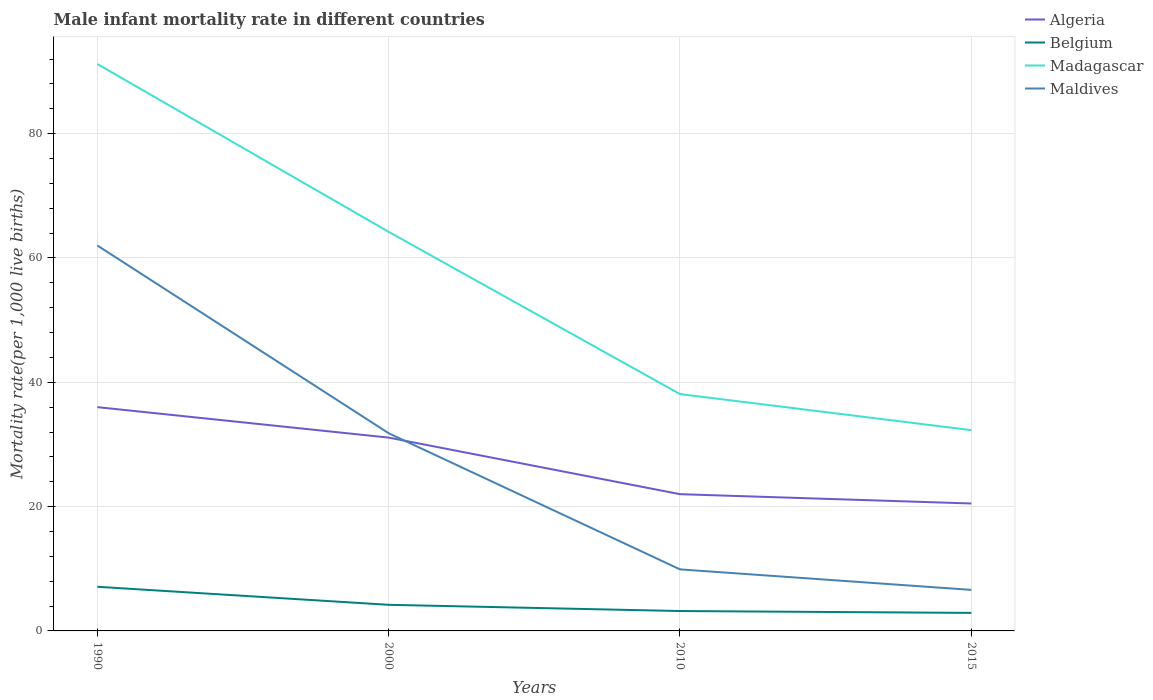How many different coloured lines are there?
Give a very brief answer. 4. Does the line corresponding to Maldives intersect with the line corresponding to Madagascar?
Your response must be concise. No. Is the number of lines equal to the number of legend labels?
Make the answer very short. Yes. In which year was the male infant mortality rate in Belgium maximum?
Your answer should be very brief. 2015. What is the total male infant mortality rate in Madagascar in the graph?
Your response must be concise. 5.8. What is the difference between the highest and the second highest male infant mortality rate in Maldives?
Keep it short and to the point. 55.4. Is the male infant mortality rate in Maldives strictly greater than the male infant mortality rate in Belgium over the years?
Your response must be concise. No. How many lines are there?
Offer a terse response. 4. How many legend labels are there?
Give a very brief answer. 4. How are the legend labels stacked?
Offer a very short reply. Vertical. What is the title of the graph?
Offer a very short reply. Male infant mortality rate in different countries. What is the label or title of the X-axis?
Provide a short and direct response. Years. What is the label or title of the Y-axis?
Provide a succinct answer. Mortality rate(per 1,0 live births). What is the Mortality rate(per 1,000 live births) in Algeria in 1990?
Provide a short and direct response. 36. What is the Mortality rate(per 1,000 live births) in Madagascar in 1990?
Offer a very short reply. 91.2. What is the Mortality rate(per 1,000 live births) in Maldives in 1990?
Offer a very short reply. 62. What is the Mortality rate(per 1,000 live births) in Algeria in 2000?
Ensure brevity in your answer.  31.1. What is the Mortality rate(per 1,000 live births) in Belgium in 2000?
Your response must be concise. 4.2. What is the Mortality rate(per 1,000 live births) in Madagascar in 2000?
Keep it short and to the point. 64.2. What is the Mortality rate(per 1,000 live births) of Maldives in 2000?
Give a very brief answer. 31.8. What is the Mortality rate(per 1,000 live births) of Madagascar in 2010?
Give a very brief answer. 38.1. What is the Mortality rate(per 1,000 live births) of Madagascar in 2015?
Provide a succinct answer. 32.3. Across all years, what is the maximum Mortality rate(per 1,000 live births) of Belgium?
Provide a succinct answer. 7.1. Across all years, what is the maximum Mortality rate(per 1,000 live births) of Madagascar?
Ensure brevity in your answer.  91.2. Across all years, what is the minimum Mortality rate(per 1,000 live births) in Algeria?
Your answer should be very brief. 20.5. Across all years, what is the minimum Mortality rate(per 1,000 live births) in Madagascar?
Give a very brief answer. 32.3. Across all years, what is the minimum Mortality rate(per 1,000 live births) of Maldives?
Provide a succinct answer. 6.6. What is the total Mortality rate(per 1,000 live births) of Algeria in the graph?
Provide a short and direct response. 109.6. What is the total Mortality rate(per 1,000 live births) of Belgium in the graph?
Provide a short and direct response. 17.4. What is the total Mortality rate(per 1,000 live births) of Madagascar in the graph?
Give a very brief answer. 225.8. What is the total Mortality rate(per 1,000 live births) in Maldives in the graph?
Provide a succinct answer. 110.3. What is the difference between the Mortality rate(per 1,000 live births) in Maldives in 1990 and that in 2000?
Give a very brief answer. 30.2. What is the difference between the Mortality rate(per 1,000 live births) in Algeria in 1990 and that in 2010?
Your answer should be very brief. 14. What is the difference between the Mortality rate(per 1,000 live births) of Madagascar in 1990 and that in 2010?
Your answer should be very brief. 53.1. What is the difference between the Mortality rate(per 1,000 live births) in Maldives in 1990 and that in 2010?
Offer a terse response. 52.1. What is the difference between the Mortality rate(per 1,000 live births) in Algeria in 1990 and that in 2015?
Keep it short and to the point. 15.5. What is the difference between the Mortality rate(per 1,000 live births) of Belgium in 1990 and that in 2015?
Your response must be concise. 4.2. What is the difference between the Mortality rate(per 1,000 live births) of Madagascar in 1990 and that in 2015?
Your answer should be very brief. 58.9. What is the difference between the Mortality rate(per 1,000 live births) of Maldives in 1990 and that in 2015?
Your answer should be very brief. 55.4. What is the difference between the Mortality rate(per 1,000 live births) of Algeria in 2000 and that in 2010?
Make the answer very short. 9.1. What is the difference between the Mortality rate(per 1,000 live births) in Madagascar in 2000 and that in 2010?
Keep it short and to the point. 26.1. What is the difference between the Mortality rate(per 1,000 live births) of Maldives in 2000 and that in 2010?
Ensure brevity in your answer.  21.9. What is the difference between the Mortality rate(per 1,000 live births) of Algeria in 2000 and that in 2015?
Offer a terse response. 10.6. What is the difference between the Mortality rate(per 1,000 live births) in Belgium in 2000 and that in 2015?
Offer a very short reply. 1.3. What is the difference between the Mortality rate(per 1,000 live births) of Madagascar in 2000 and that in 2015?
Offer a very short reply. 31.9. What is the difference between the Mortality rate(per 1,000 live births) in Maldives in 2000 and that in 2015?
Give a very brief answer. 25.2. What is the difference between the Mortality rate(per 1,000 live births) of Madagascar in 2010 and that in 2015?
Ensure brevity in your answer.  5.8. What is the difference between the Mortality rate(per 1,000 live births) in Algeria in 1990 and the Mortality rate(per 1,000 live births) in Belgium in 2000?
Your answer should be compact. 31.8. What is the difference between the Mortality rate(per 1,000 live births) of Algeria in 1990 and the Mortality rate(per 1,000 live births) of Madagascar in 2000?
Ensure brevity in your answer.  -28.2. What is the difference between the Mortality rate(per 1,000 live births) in Algeria in 1990 and the Mortality rate(per 1,000 live births) in Maldives in 2000?
Your response must be concise. 4.2. What is the difference between the Mortality rate(per 1,000 live births) in Belgium in 1990 and the Mortality rate(per 1,000 live births) in Madagascar in 2000?
Provide a succinct answer. -57.1. What is the difference between the Mortality rate(per 1,000 live births) in Belgium in 1990 and the Mortality rate(per 1,000 live births) in Maldives in 2000?
Offer a terse response. -24.7. What is the difference between the Mortality rate(per 1,000 live births) in Madagascar in 1990 and the Mortality rate(per 1,000 live births) in Maldives in 2000?
Your response must be concise. 59.4. What is the difference between the Mortality rate(per 1,000 live births) of Algeria in 1990 and the Mortality rate(per 1,000 live births) of Belgium in 2010?
Your answer should be compact. 32.8. What is the difference between the Mortality rate(per 1,000 live births) of Algeria in 1990 and the Mortality rate(per 1,000 live births) of Maldives in 2010?
Your answer should be compact. 26.1. What is the difference between the Mortality rate(per 1,000 live births) of Belgium in 1990 and the Mortality rate(per 1,000 live births) of Madagascar in 2010?
Your response must be concise. -31. What is the difference between the Mortality rate(per 1,000 live births) in Madagascar in 1990 and the Mortality rate(per 1,000 live births) in Maldives in 2010?
Offer a terse response. 81.3. What is the difference between the Mortality rate(per 1,000 live births) in Algeria in 1990 and the Mortality rate(per 1,000 live births) in Belgium in 2015?
Keep it short and to the point. 33.1. What is the difference between the Mortality rate(per 1,000 live births) in Algeria in 1990 and the Mortality rate(per 1,000 live births) in Madagascar in 2015?
Keep it short and to the point. 3.7. What is the difference between the Mortality rate(per 1,000 live births) in Algeria in 1990 and the Mortality rate(per 1,000 live births) in Maldives in 2015?
Keep it short and to the point. 29.4. What is the difference between the Mortality rate(per 1,000 live births) of Belgium in 1990 and the Mortality rate(per 1,000 live births) of Madagascar in 2015?
Give a very brief answer. -25.2. What is the difference between the Mortality rate(per 1,000 live births) of Madagascar in 1990 and the Mortality rate(per 1,000 live births) of Maldives in 2015?
Offer a terse response. 84.6. What is the difference between the Mortality rate(per 1,000 live births) of Algeria in 2000 and the Mortality rate(per 1,000 live births) of Belgium in 2010?
Your answer should be compact. 27.9. What is the difference between the Mortality rate(per 1,000 live births) in Algeria in 2000 and the Mortality rate(per 1,000 live births) in Maldives in 2010?
Your answer should be very brief. 21.2. What is the difference between the Mortality rate(per 1,000 live births) in Belgium in 2000 and the Mortality rate(per 1,000 live births) in Madagascar in 2010?
Offer a terse response. -33.9. What is the difference between the Mortality rate(per 1,000 live births) of Belgium in 2000 and the Mortality rate(per 1,000 live births) of Maldives in 2010?
Make the answer very short. -5.7. What is the difference between the Mortality rate(per 1,000 live births) in Madagascar in 2000 and the Mortality rate(per 1,000 live births) in Maldives in 2010?
Provide a succinct answer. 54.3. What is the difference between the Mortality rate(per 1,000 live births) of Algeria in 2000 and the Mortality rate(per 1,000 live births) of Belgium in 2015?
Your answer should be very brief. 28.2. What is the difference between the Mortality rate(per 1,000 live births) of Belgium in 2000 and the Mortality rate(per 1,000 live births) of Madagascar in 2015?
Offer a terse response. -28.1. What is the difference between the Mortality rate(per 1,000 live births) in Belgium in 2000 and the Mortality rate(per 1,000 live births) in Maldives in 2015?
Provide a succinct answer. -2.4. What is the difference between the Mortality rate(per 1,000 live births) of Madagascar in 2000 and the Mortality rate(per 1,000 live births) of Maldives in 2015?
Ensure brevity in your answer.  57.6. What is the difference between the Mortality rate(per 1,000 live births) of Algeria in 2010 and the Mortality rate(per 1,000 live births) of Madagascar in 2015?
Keep it short and to the point. -10.3. What is the difference between the Mortality rate(per 1,000 live births) in Algeria in 2010 and the Mortality rate(per 1,000 live births) in Maldives in 2015?
Give a very brief answer. 15.4. What is the difference between the Mortality rate(per 1,000 live births) in Belgium in 2010 and the Mortality rate(per 1,000 live births) in Madagascar in 2015?
Ensure brevity in your answer.  -29.1. What is the difference between the Mortality rate(per 1,000 live births) of Belgium in 2010 and the Mortality rate(per 1,000 live births) of Maldives in 2015?
Provide a short and direct response. -3.4. What is the difference between the Mortality rate(per 1,000 live births) in Madagascar in 2010 and the Mortality rate(per 1,000 live births) in Maldives in 2015?
Your response must be concise. 31.5. What is the average Mortality rate(per 1,000 live births) in Algeria per year?
Give a very brief answer. 27.4. What is the average Mortality rate(per 1,000 live births) in Belgium per year?
Ensure brevity in your answer.  4.35. What is the average Mortality rate(per 1,000 live births) in Madagascar per year?
Provide a succinct answer. 56.45. What is the average Mortality rate(per 1,000 live births) of Maldives per year?
Offer a very short reply. 27.57. In the year 1990, what is the difference between the Mortality rate(per 1,000 live births) in Algeria and Mortality rate(per 1,000 live births) in Belgium?
Give a very brief answer. 28.9. In the year 1990, what is the difference between the Mortality rate(per 1,000 live births) of Algeria and Mortality rate(per 1,000 live births) of Madagascar?
Keep it short and to the point. -55.2. In the year 1990, what is the difference between the Mortality rate(per 1,000 live births) of Algeria and Mortality rate(per 1,000 live births) of Maldives?
Ensure brevity in your answer.  -26. In the year 1990, what is the difference between the Mortality rate(per 1,000 live births) in Belgium and Mortality rate(per 1,000 live births) in Madagascar?
Your answer should be compact. -84.1. In the year 1990, what is the difference between the Mortality rate(per 1,000 live births) in Belgium and Mortality rate(per 1,000 live births) in Maldives?
Provide a short and direct response. -54.9. In the year 1990, what is the difference between the Mortality rate(per 1,000 live births) of Madagascar and Mortality rate(per 1,000 live births) of Maldives?
Offer a terse response. 29.2. In the year 2000, what is the difference between the Mortality rate(per 1,000 live births) in Algeria and Mortality rate(per 1,000 live births) in Belgium?
Offer a terse response. 26.9. In the year 2000, what is the difference between the Mortality rate(per 1,000 live births) of Algeria and Mortality rate(per 1,000 live births) of Madagascar?
Keep it short and to the point. -33.1. In the year 2000, what is the difference between the Mortality rate(per 1,000 live births) of Belgium and Mortality rate(per 1,000 live births) of Madagascar?
Offer a terse response. -60. In the year 2000, what is the difference between the Mortality rate(per 1,000 live births) in Belgium and Mortality rate(per 1,000 live births) in Maldives?
Keep it short and to the point. -27.6. In the year 2000, what is the difference between the Mortality rate(per 1,000 live births) in Madagascar and Mortality rate(per 1,000 live births) in Maldives?
Provide a short and direct response. 32.4. In the year 2010, what is the difference between the Mortality rate(per 1,000 live births) of Algeria and Mortality rate(per 1,000 live births) of Madagascar?
Make the answer very short. -16.1. In the year 2010, what is the difference between the Mortality rate(per 1,000 live births) of Belgium and Mortality rate(per 1,000 live births) of Madagascar?
Provide a short and direct response. -34.9. In the year 2010, what is the difference between the Mortality rate(per 1,000 live births) in Belgium and Mortality rate(per 1,000 live births) in Maldives?
Offer a terse response. -6.7. In the year 2010, what is the difference between the Mortality rate(per 1,000 live births) of Madagascar and Mortality rate(per 1,000 live births) of Maldives?
Keep it short and to the point. 28.2. In the year 2015, what is the difference between the Mortality rate(per 1,000 live births) in Algeria and Mortality rate(per 1,000 live births) in Madagascar?
Provide a short and direct response. -11.8. In the year 2015, what is the difference between the Mortality rate(per 1,000 live births) of Belgium and Mortality rate(per 1,000 live births) of Madagascar?
Your answer should be compact. -29.4. In the year 2015, what is the difference between the Mortality rate(per 1,000 live births) in Belgium and Mortality rate(per 1,000 live births) in Maldives?
Ensure brevity in your answer.  -3.7. In the year 2015, what is the difference between the Mortality rate(per 1,000 live births) in Madagascar and Mortality rate(per 1,000 live births) in Maldives?
Your answer should be very brief. 25.7. What is the ratio of the Mortality rate(per 1,000 live births) of Algeria in 1990 to that in 2000?
Provide a short and direct response. 1.16. What is the ratio of the Mortality rate(per 1,000 live births) in Belgium in 1990 to that in 2000?
Your answer should be very brief. 1.69. What is the ratio of the Mortality rate(per 1,000 live births) in Madagascar in 1990 to that in 2000?
Provide a succinct answer. 1.42. What is the ratio of the Mortality rate(per 1,000 live births) in Maldives in 1990 to that in 2000?
Keep it short and to the point. 1.95. What is the ratio of the Mortality rate(per 1,000 live births) of Algeria in 1990 to that in 2010?
Your response must be concise. 1.64. What is the ratio of the Mortality rate(per 1,000 live births) in Belgium in 1990 to that in 2010?
Provide a short and direct response. 2.22. What is the ratio of the Mortality rate(per 1,000 live births) of Madagascar in 1990 to that in 2010?
Make the answer very short. 2.39. What is the ratio of the Mortality rate(per 1,000 live births) of Maldives in 1990 to that in 2010?
Offer a terse response. 6.26. What is the ratio of the Mortality rate(per 1,000 live births) in Algeria in 1990 to that in 2015?
Keep it short and to the point. 1.76. What is the ratio of the Mortality rate(per 1,000 live births) of Belgium in 1990 to that in 2015?
Provide a succinct answer. 2.45. What is the ratio of the Mortality rate(per 1,000 live births) of Madagascar in 1990 to that in 2015?
Your answer should be compact. 2.82. What is the ratio of the Mortality rate(per 1,000 live births) in Maldives in 1990 to that in 2015?
Make the answer very short. 9.39. What is the ratio of the Mortality rate(per 1,000 live births) of Algeria in 2000 to that in 2010?
Your answer should be compact. 1.41. What is the ratio of the Mortality rate(per 1,000 live births) in Belgium in 2000 to that in 2010?
Your answer should be compact. 1.31. What is the ratio of the Mortality rate(per 1,000 live births) of Madagascar in 2000 to that in 2010?
Your response must be concise. 1.69. What is the ratio of the Mortality rate(per 1,000 live births) of Maldives in 2000 to that in 2010?
Make the answer very short. 3.21. What is the ratio of the Mortality rate(per 1,000 live births) in Algeria in 2000 to that in 2015?
Make the answer very short. 1.52. What is the ratio of the Mortality rate(per 1,000 live births) of Belgium in 2000 to that in 2015?
Your answer should be very brief. 1.45. What is the ratio of the Mortality rate(per 1,000 live births) in Madagascar in 2000 to that in 2015?
Your answer should be very brief. 1.99. What is the ratio of the Mortality rate(per 1,000 live births) in Maldives in 2000 to that in 2015?
Provide a short and direct response. 4.82. What is the ratio of the Mortality rate(per 1,000 live births) in Algeria in 2010 to that in 2015?
Your answer should be compact. 1.07. What is the ratio of the Mortality rate(per 1,000 live births) in Belgium in 2010 to that in 2015?
Keep it short and to the point. 1.1. What is the ratio of the Mortality rate(per 1,000 live births) in Madagascar in 2010 to that in 2015?
Offer a very short reply. 1.18. What is the difference between the highest and the second highest Mortality rate(per 1,000 live births) in Madagascar?
Provide a succinct answer. 27. What is the difference between the highest and the second highest Mortality rate(per 1,000 live births) of Maldives?
Provide a succinct answer. 30.2. What is the difference between the highest and the lowest Mortality rate(per 1,000 live births) of Algeria?
Give a very brief answer. 15.5. What is the difference between the highest and the lowest Mortality rate(per 1,000 live births) in Belgium?
Give a very brief answer. 4.2. What is the difference between the highest and the lowest Mortality rate(per 1,000 live births) of Madagascar?
Your answer should be compact. 58.9. What is the difference between the highest and the lowest Mortality rate(per 1,000 live births) of Maldives?
Offer a very short reply. 55.4. 